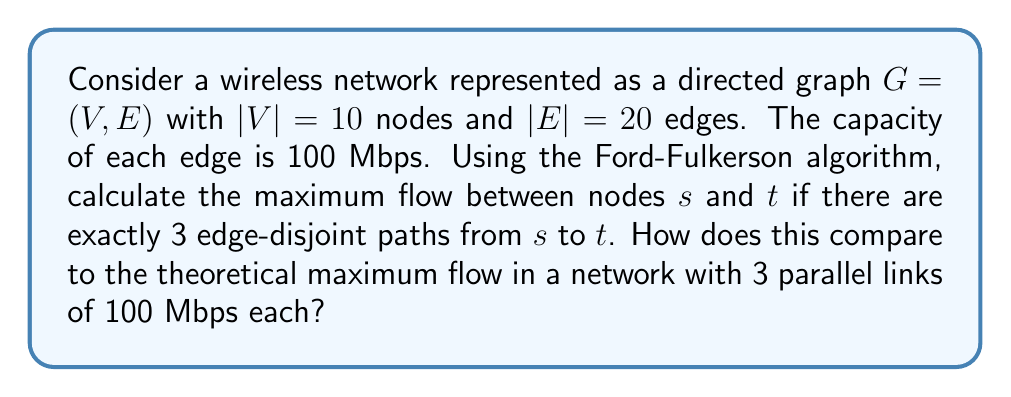Help me with this question. To solve this problem, we'll follow these steps:

1) First, recall that the Ford-Fulkerson algorithm finds the maximum flow in a network by repeatedly finding augmenting paths and increasing the flow along these paths until no more augmenting paths exist.

2) Given that there are exactly 3 edge-disjoint paths from $s$ to $t$, this means that the min-cut of the network consists of these 3 edges.

3) The Ford-Fulkerson algorithm will find these 3 paths and saturate them. Since each edge has a capacity of 100 Mbps, the maximum flow through each path will be 100 Mbps.

4) Therefore, the maximum flow from $s$ to $t$ will be:

   $$ \text{Max Flow} = 3 \times 100 \text{ Mbps} = 300 \text{ Mbps} $$

5) Now, let's compare this to a network with 3 parallel links of 100 Mbps each:

   In such a network, we would also have a maximum flow of 300 Mbps, as each link can carry 100 Mbps independently.

6) Therefore, our original network, despite having more nodes and edges, achieves the same maximum flow as the simplified network with just 3 parallel links.

This demonstrates that the efficiency of the routing in our original network is optimal, as it achieves the theoretical maximum flow possible with 3 edge-disjoint paths.
Answer: 300 Mbps; equal to theoretical maximum 